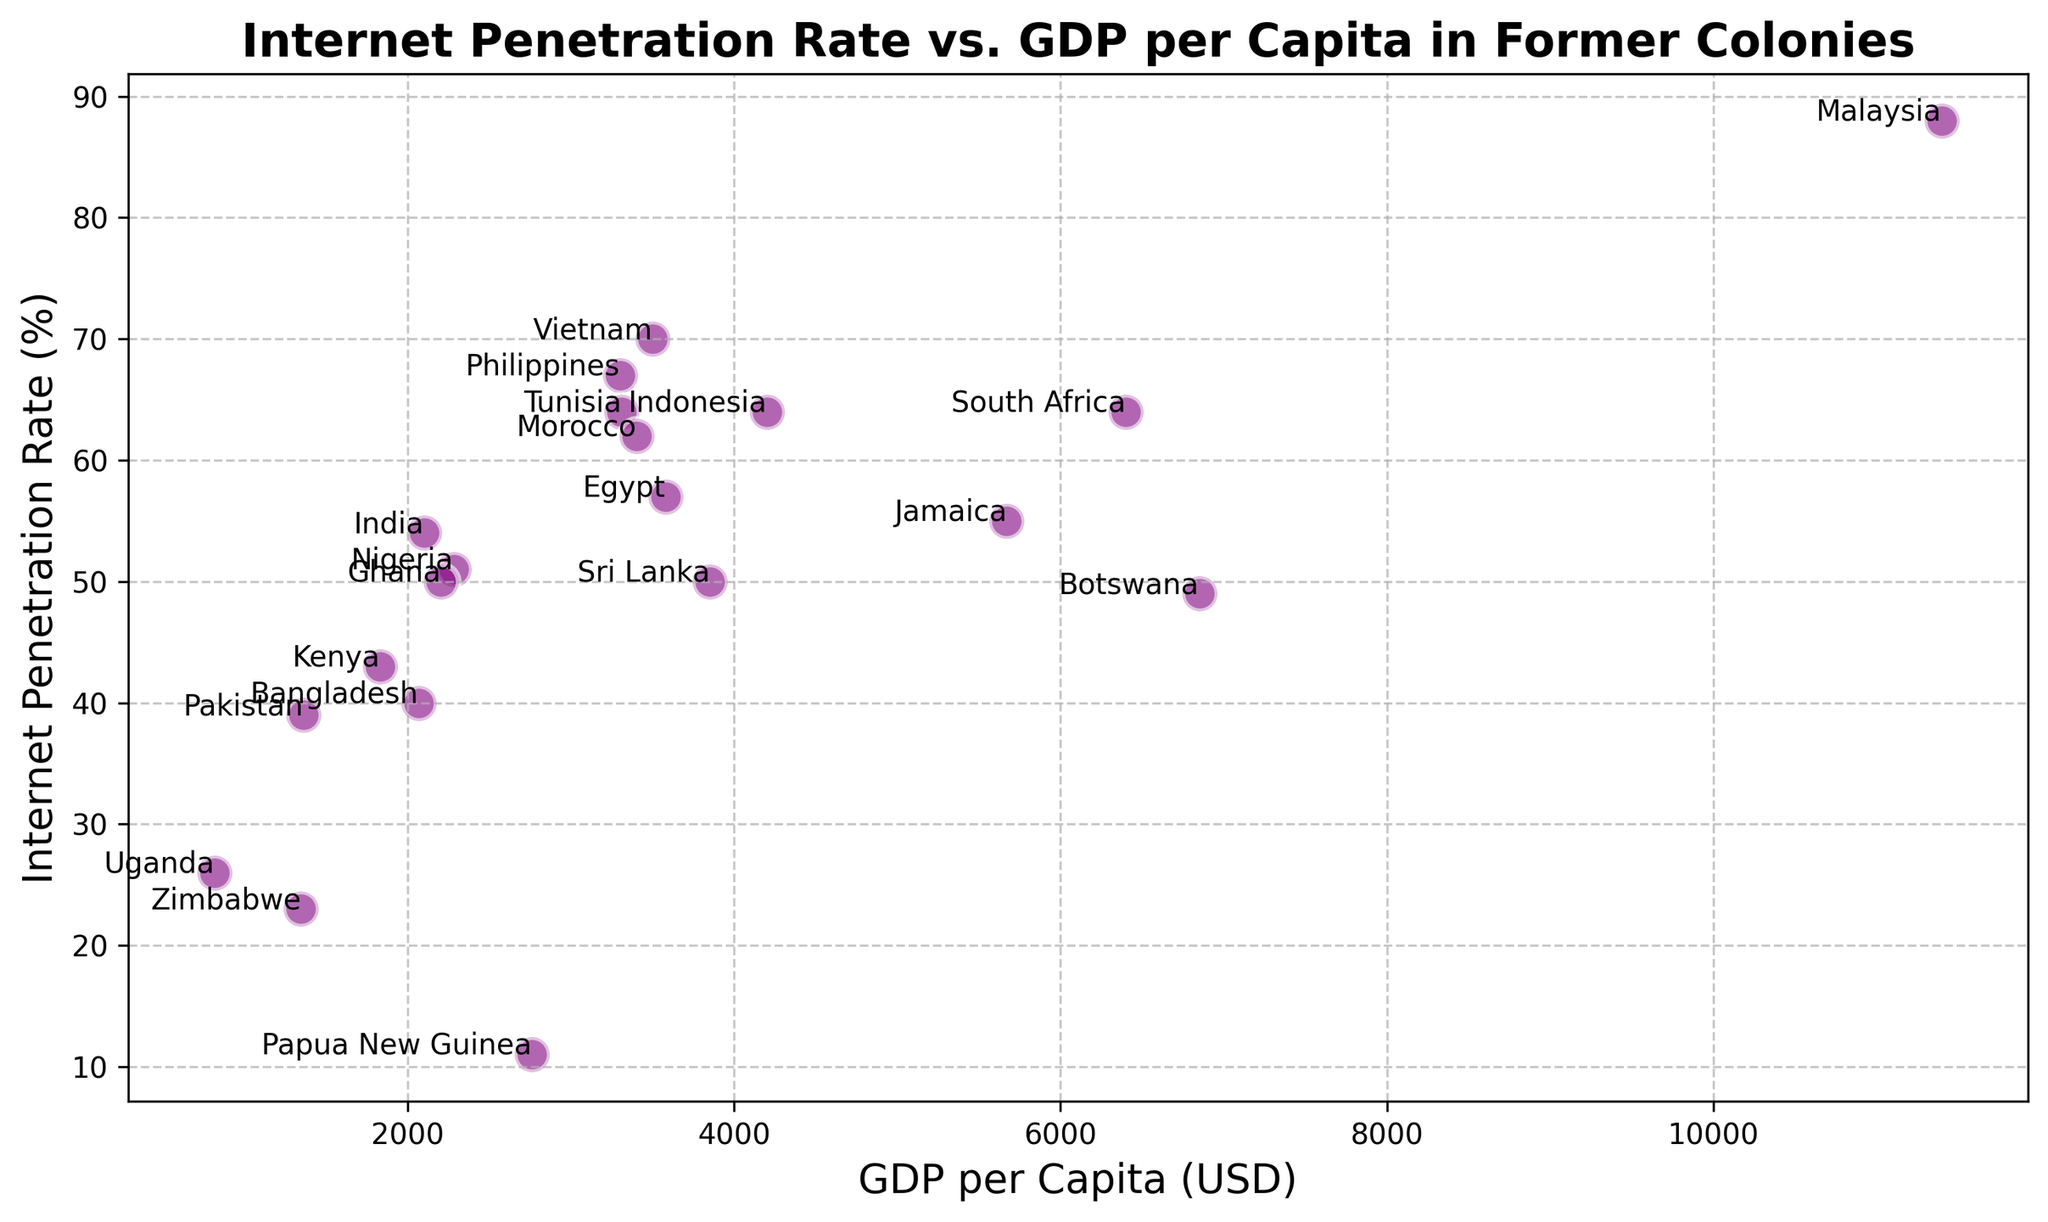1. Which country has the highest Internet Penetration Rate, and what is its value? By looking at the scatter plot, locate the point with the highest percentage on the y-axis (Internet Penetration Rate). The annotation will show the country's name and the exact Internet Penetration Rate percentage.
Answer: Malaysia, 88% 2. What is the GDP per capita of the country with the lowest Internet Penetration Rate? Find the point on the scatter plot with the lowest y-value, which represents the Internet Penetration Rate. The corresponding x-value and country annotation will give the GDP per capita.
Answer: Papua New Guinea, 2760 USD 3. How many countries have an Internet Penetration Rate greater than 60%? Count all the points on the scatter plot that are positioned above 60% on the y-axis. Each point represents a country.
Answer: 6 4. Compare two countries: India and Malaysia. Which has a higher GDP per capita and what is the difference in their Internet Penetration Rates? Locate the points for India and Malaysia on the scatter plot. Identify their GDP per capita and Internet Penetration Rate values. Subtract the values for Internet Penetration Rate to determine the difference.
Answer: Malaysia has a higher GDP per capita. The difference in Internet Penetration Rates is 34% 5. What is the average Internet Penetration Rate across all listed countries? Sum all the Internet Penetration Rate percentages from the countries listed. Divide the total by the number of countries to find the average rate. Though this would need calculation, estimating from the plot's general height range can give a rough figure.
Answer: 51.7 (approx.) 6. Which two countries have Internet Penetration Rates closest to each other, and what are their values? Look for points on the scatter plot that are nearly at the same height on the y-axis. Check their annotated values to confirm the smallest difference.
Answer: Botswana and Sri Lanka, both have 50% 9. What trend (if any) can be observed between Internet Penetration Rate and GDP per Capita? Examine the plotted points to see if there's a general pattern or trend line direction associating GDP per Capita with Internet Penetration Rate.
Answer: Generally, a higher GDP per Capita correlates with a higher Internet Penetration Rate 10. Compared to Nigeria, which country has a higher Internet Penetration Rate with a similar GDP per Capita? Find Nigeria on the plot, then search for another country that is horizontally close (similar GDP) but vertically higher (higher Internet Penetration). Nigeria has a GDP per Capita of 2280 USD and a 51% Internet Penetration Rate. Ghana is close in GDP and has a higher penetration rate.
Answer: Ghana, 50% Internet Penetration Rate 